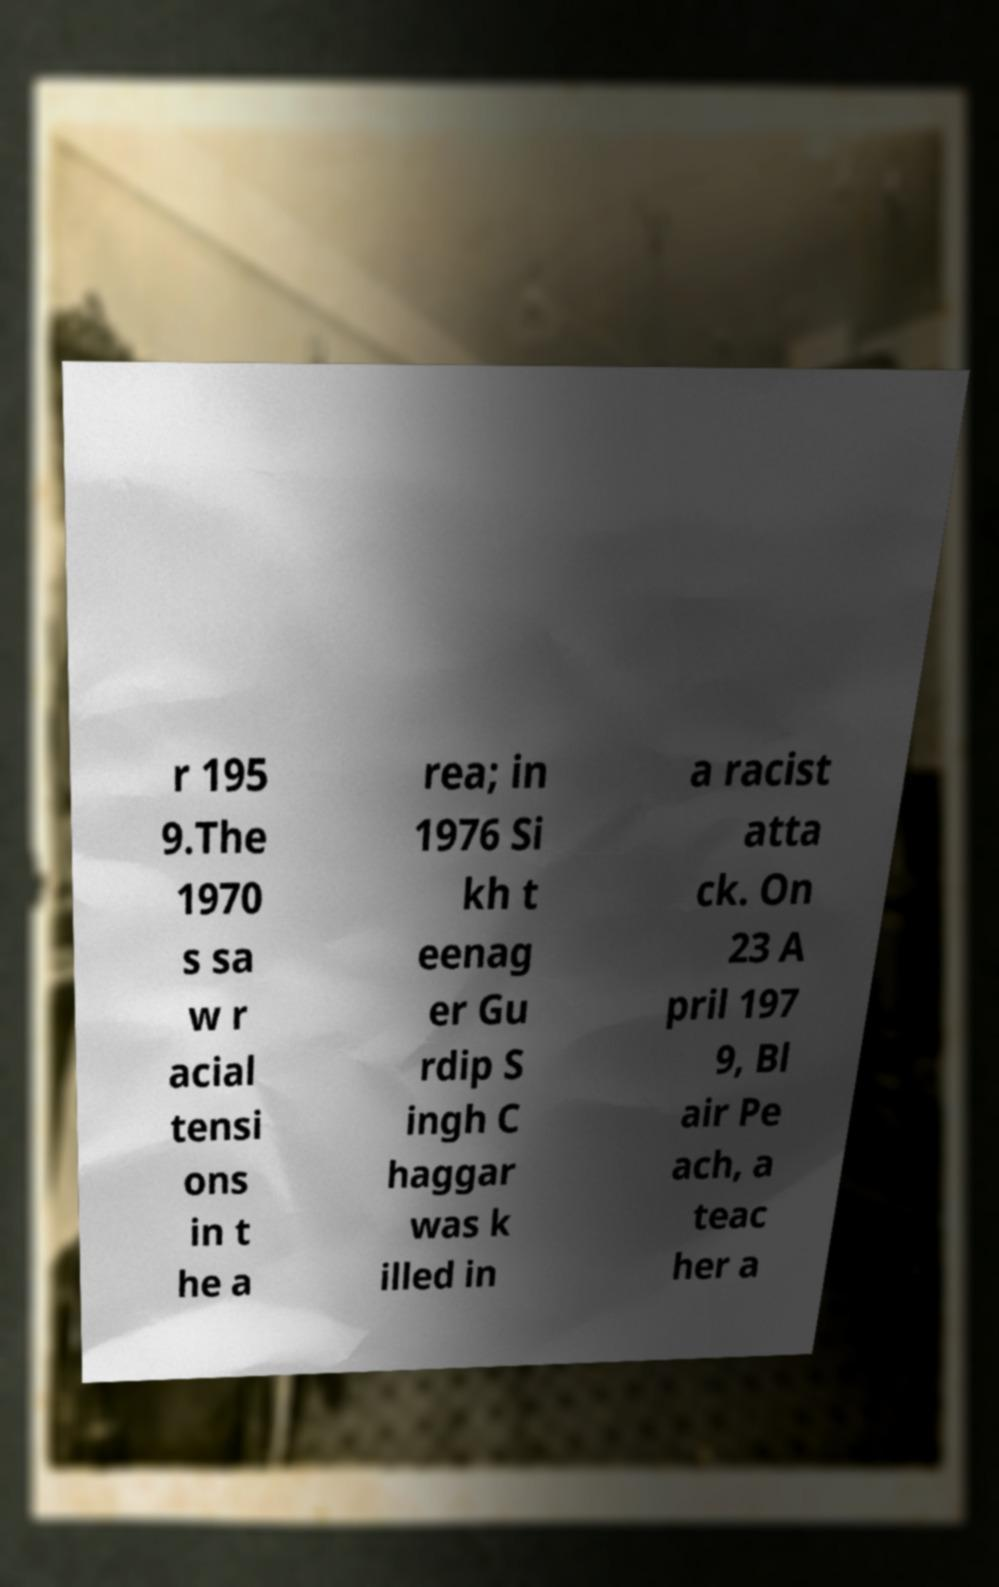Could you extract and type out the text from this image? r 195 9.The 1970 s sa w r acial tensi ons in t he a rea; in 1976 Si kh t eenag er Gu rdip S ingh C haggar was k illed in a racist atta ck. On 23 A pril 197 9, Bl air Pe ach, a teac her a 